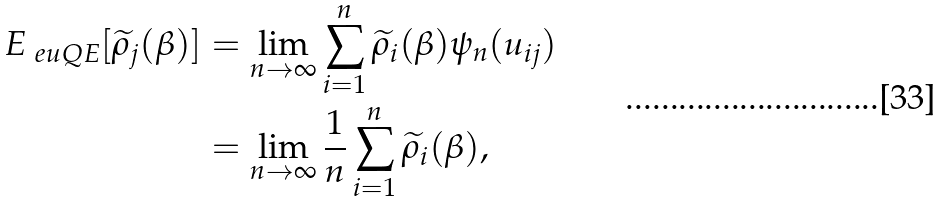Convert formula to latex. <formula><loc_0><loc_0><loc_500><loc_500>E _ { \ e u { Q E } } [ \widetilde { \rho } _ { j } ( \beta ) ] & = \lim _ { n \to \infty } \sum _ { i = 1 } ^ { n } \widetilde { \rho } _ { i } ( \beta ) \psi _ { n } ( u _ { i j } ) \\ & = \lim _ { n \to \infty } \frac { 1 } { n } \sum _ { i = 1 } ^ { n } \widetilde { \rho } _ { i } ( \beta ) ,</formula> 